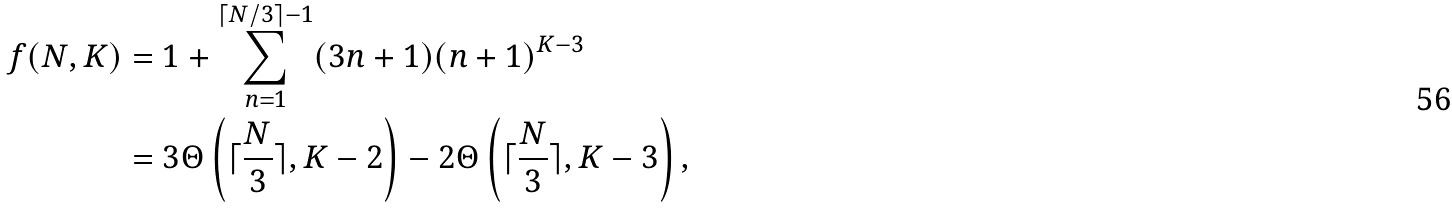Convert formula to latex. <formula><loc_0><loc_0><loc_500><loc_500>f ( N , K ) & = 1 + \sum _ { n = 1 } ^ { \lceil N / 3 \rceil - 1 } ( 3 n + 1 ) ( n + 1 ) ^ { K - 3 } \\ & = 3 \Theta \left ( \lceil \frac { N } { 3 } \rceil , K - 2 \right ) - 2 \Theta \left ( \lceil \frac { N } { 3 } \rceil , K - 3 \right ) ,</formula> 